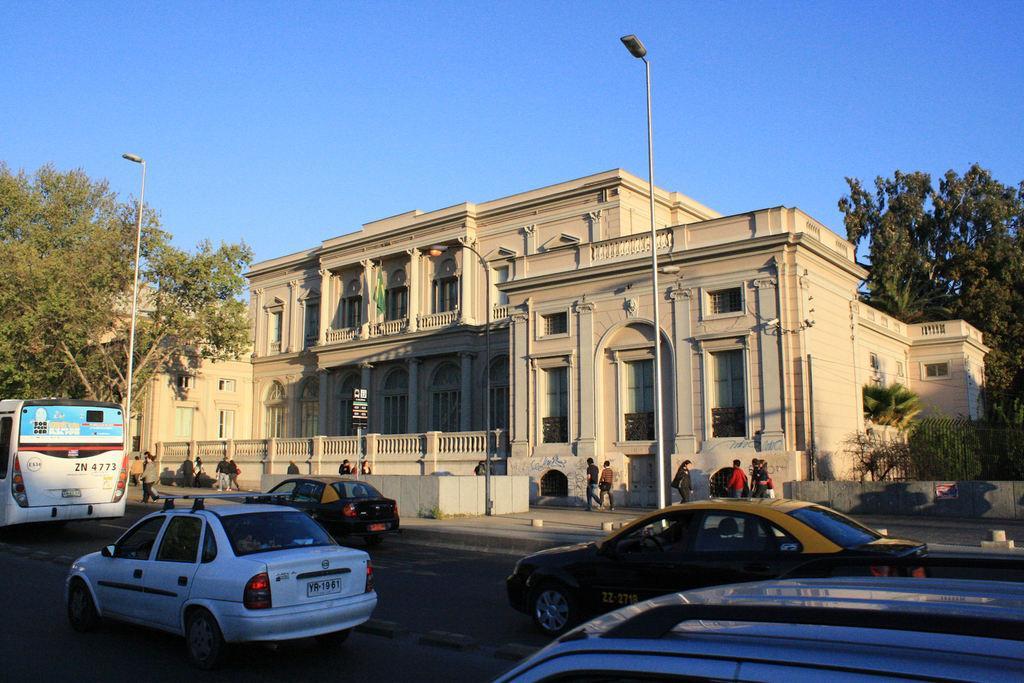In one or two sentences, can you explain what this image depicts? In this picture we can see a few vehicles on the road. There are some people and street lights are visible on the path. We can see a black board on a pole. There are a few trees and a building in the background. Sky is blue in color. 